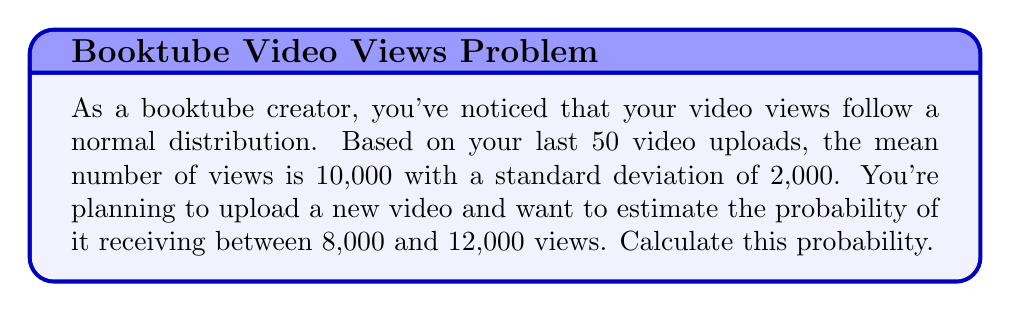Teach me how to tackle this problem. To solve this problem, we need to use the properties of the normal distribution and the concept of z-scores.

1) First, let's define our variables:
   $\mu = 10,000$ (mean views)
   $\sigma = 2,000$ (standard deviation)
   Lower bound: 8,000 views
   Upper bound: 12,000 views

2) We need to convert these view counts to z-scores using the formula:
   $z = \frac{x - \mu}{\sigma}$

   For the lower bound: $z_1 = \frac{8,000 - 10,000}{2,000} = -1$
   For the upper bound: $z_2 = \frac{12,000 - 10,000}{2,000} = 1$

3) Now, we need to find the area under the standard normal curve between these z-scores. This can be done using a standard normal table or a calculator with a built-in function.

4) The probability is equal to:
   $P(-1 < Z < 1) = P(Z < 1) - P(Z < -1)$

5) Using a standard normal table or calculator:
   $P(Z < 1) \approx 0.8413$
   $P(Z < -1) \approx 0.1587$

6) Therefore, the probability is:
   $P(-1 < Z < 1) = 0.8413 - 0.1587 = 0.6826$

This means there's approximately a 68.26% chance that your new video will receive between 8,000 and 12,000 views.
Answer: The probability that the new video will receive between 8,000 and 12,000 views is approximately 0.6826 or 68.26%. 